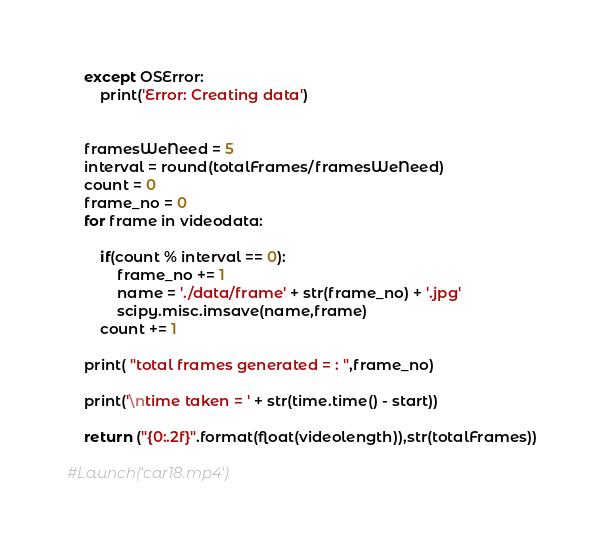<code> <loc_0><loc_0><loc_500><loc_500><_Python_>
    except OSError:
        print('Error: Creating data')

  
    framesWeNeed = 5
    interval = round(totalFrames/framesWeNeed)
    count = 0
    frame_no = 0
    for frame in videodata:
        
        if(count % interval == 0):
            frame_no += 1
            name = './data/frame' + str(frame_no) + '.jpg'
            scipy.misc.imsave(name,frame) 
        count += 1
    
    print( "total frames generated = : ",frame_no)   
    
    print('\ntime taken = ' + str(time.time() - start))
    
    return ("{0:.2f}".format(float(videolength)),str(totalFrames))
    
#Launch('car18.mp4')
</code> 